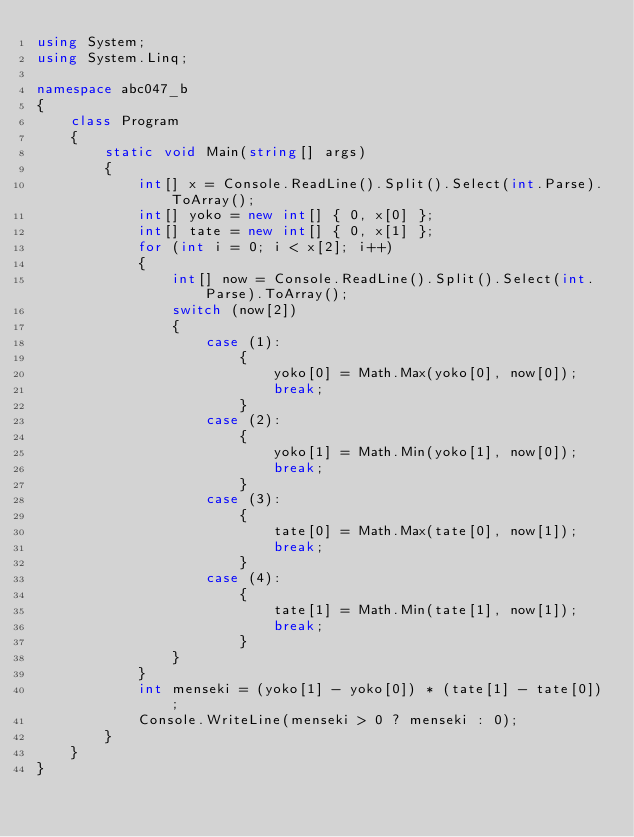<code> <loc_0><loc_0><loc_500><loc_500><_C#_>using System;
using System.Linq;

namespace abc047_b
{
    class Program
    {
        static void Main(string[] args)
        {
            int[] x = Console.ReadLine().Split().Select(int.Parse).ToArray();
            int[] yoko = new int[] { 0, x[0] };
            int[] tate = new int[] { 0, x[1] };
            for (int i = 0; i < x[2]; i++)
            {
                int[] now = Console.ReadLine().Split().Select(int.Parse).ToArray();
                switch (now[2])
                {
                    case (1):
                        {
                            yoko[0] = Math.Max(yoko[0], now[0]);
                            break;
                        }
                    case (2):
                        {
                            yoko[1] = Math.Min(yoko[1], now[0]);
                            break;
                        }
                    case (3):
                        {
                            tate[0] = Math.Max(tate[0], now[1]);
                            break;
                        }
                    case (4):
                        {
                            tate[1] = Math.Min(tate[1], now[1]);
                            break;
                        }
                }
            }
            int menseki = (yoko[1] - yoko[0]) * (tate[1] - tate[0]);
            Console.WriteLine(menseki > 0 ? menseki : 0);
        }
    }
}</code> 